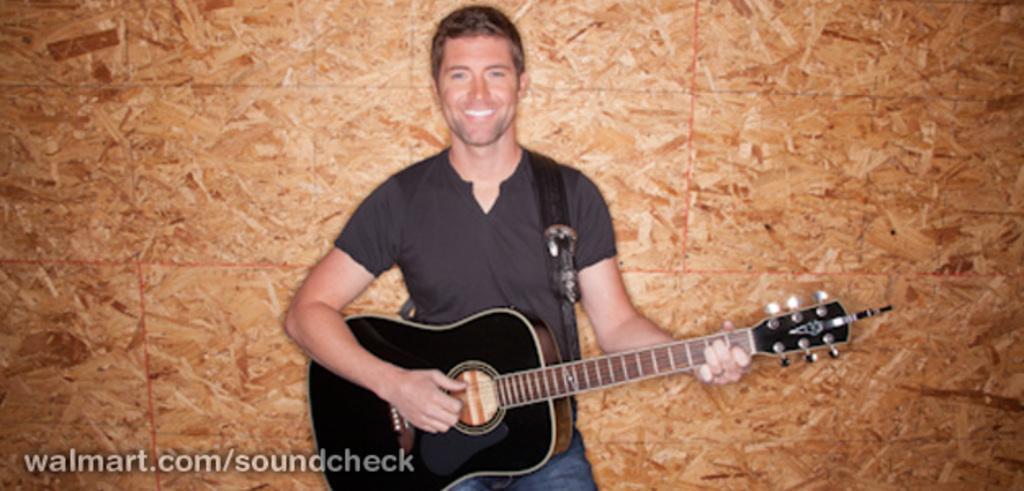Describe this image in one or two sentences. A man with black t-shirt is standing and playing guitar. He is smiling. 